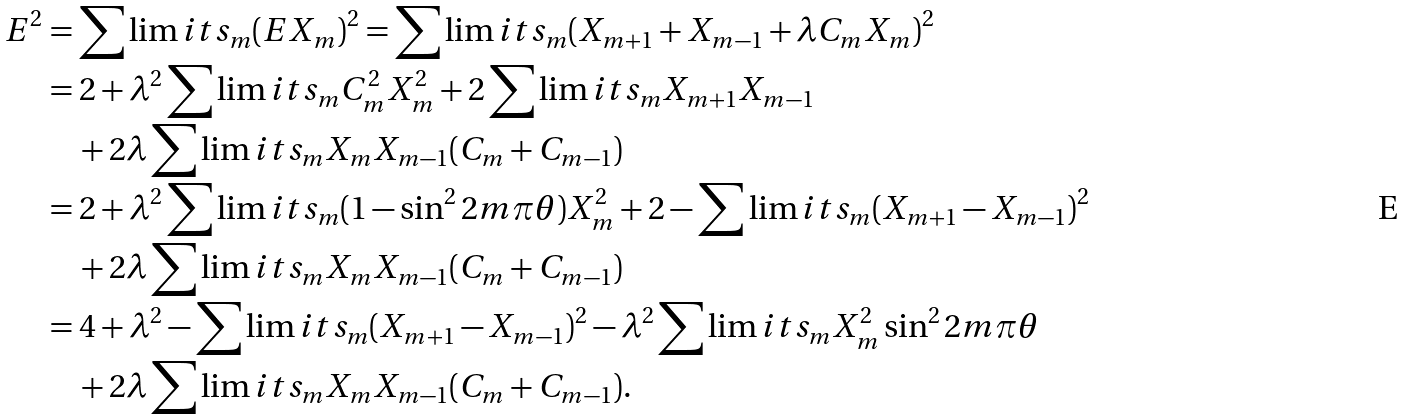<formula> <loc_0><loc_0><loc_500><loc_500>E ^ { 2 } & = \sum \lim i t s _ { m } ( E X _ { m } ) ^ { 2 } = \sum \lim i t s _ { m } ( X _ { m + 1 } + X _ { m - 1 } + \lambda C _ { m } X _ { m } ) ^ { 2 } \\ & = 2 + \lambda ^ { 2 } \sum \lim i t s _ { m } C _ { m } ^ { 2 } X _ { m } ^ { 2 } + 2 \sum \lim i t s _ { m } X _ { m + 1 } X _ { m - 1 } \\ & \quad + 2 \lambda \sum \lim i t s _ { m } X _ { m } X _ { m - 1 } ( C _ { m } + C _ { m - 1 } ) \\ & = 2 + \lambda ^ { 2 } \sum \lim i t s _ { m } ( 1 - \sin ^ { 2 } 2 m \pi \theta ) X _ { m } ^ { 2 } + 2 - \sum \lim i t s _ { m } ( X _ { m + 1 } - X _ { m - 1 } ) ^ { 2 } \\ & \quad + 2 \lambda \sum \lim i t s _ { m } X _ { m } X _ { m - 1 } ( C _ { m } + C _ { m - 1 } ) \\ & = 4 + \lambda ^ { 2 } - \sum \lim i t s _ { m } ( X _ { m + 1 } - X _ { m - 1 } ) ^ { 2 } - \lambda ^ { 2 } \sum \lim i t s _ { m } X _ { m } ^ { 2 } \sin ^ { 2 } 2 m \pi \theta \\ & \quad + 2 \lambda \sum \lim i t s _ { m } X _ { m } X _ { m - 1 } ( C _ { m } + C _ { m - 1 } ) .</formula> 